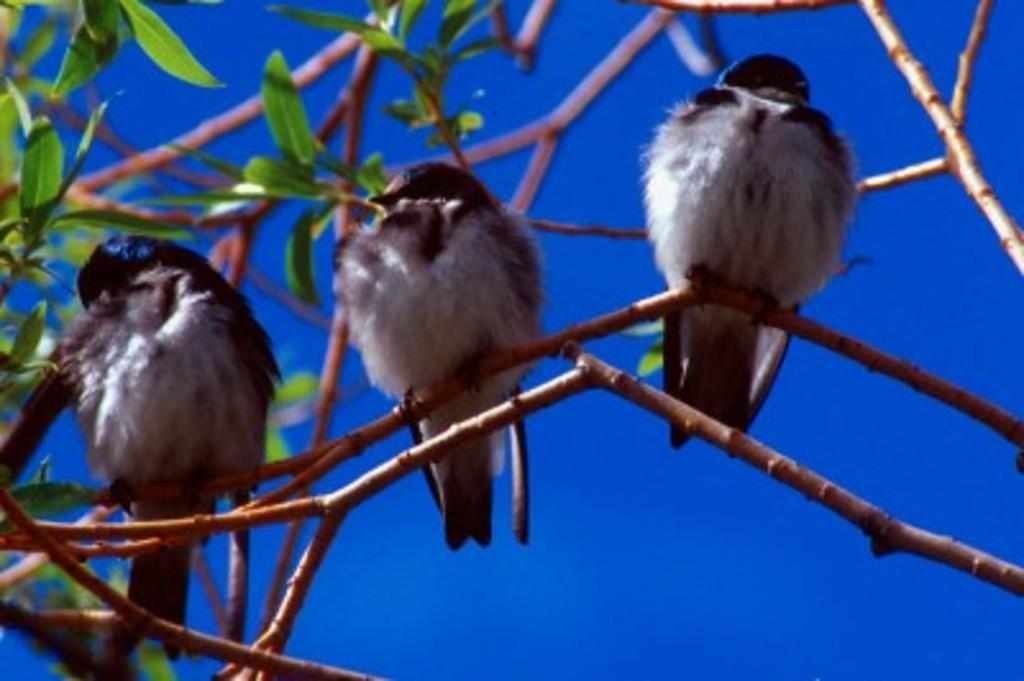Please provide a concise description of this image. In this picture we can see three birds on a branch of a tree and in the background we can see the sky. 